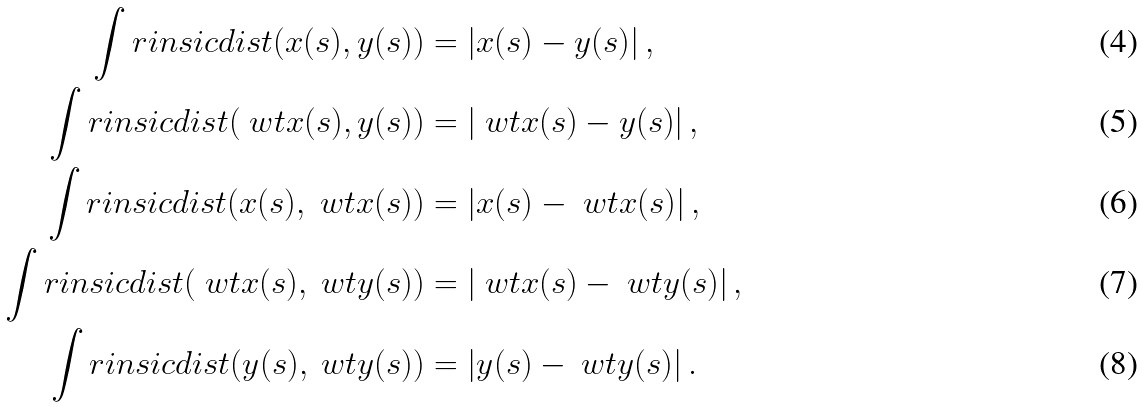Convert formula to latex. <formula><loc_0><loc_0><loc_500><loc_500>\int r i n s i c d i s t ( x ( s ) , y ( s ) ) & = | { x ( s ) } - { y ( s ) } | \, , \\ \int r i n s i c d i s t ( \ w t x ( s ) , y ( s ) ) & = | { \ w t x ( s ) } - { y ( s ) } | \, , \\ \int r i n s i c d i s t ( x ( s ) , \ w t x ( s ) ) & = | { x ( s ) } - { \ w t x ( s ) } | \, , \\ \int r i n s i c d i s t ( \ w t x ( s ) , \ w t y ( s ) ) & = | { \ w t x ( s ) } - { \ w t y ( s ) } | \, , \\ \int r i n s i c d i s t ( y ( s ) , \ w t y ( s ) ) & = | { y ( s ) } - { \ w t y ( s ) } | \, .</formula> 